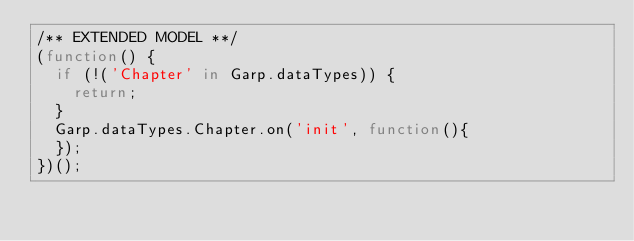Convert code to text. <code><loc_0><loc_0><loc_500><loc_500><_JavaScript_>/** EXTENDED MODEL **/
(function() {
	if (!('Chapter' in Garp.dataTypes)) {
		return;
	}
	Garp.dataTypes.Chapter.on('init', function(){
	});
})();
</code> 